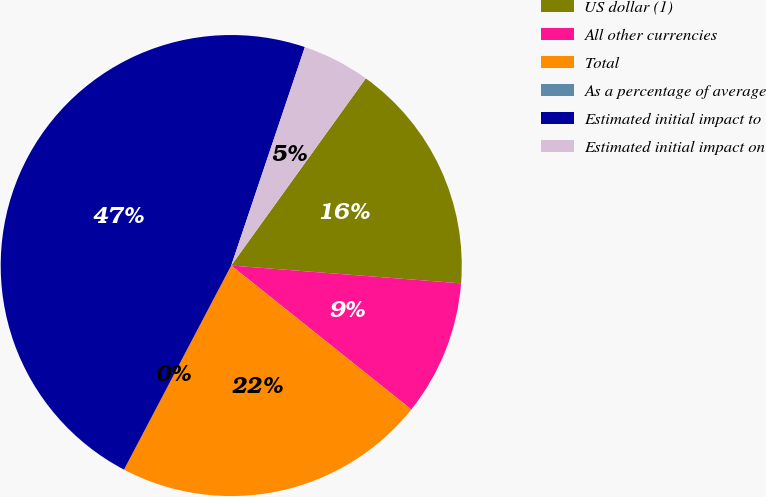Convert chart to OTSL. <chart><loc_0><loc_0><loc_500><loc_500><pie_chart><fcel>US dollar (1)<fcel>All other currencies<fcel>Total<fcel>As a percentage of average<fcel>Estimated initial impact to<fcel>Estimated initial impact on<nl><fcel>16.31%<fcel>9.5%<fcel>21.97%<fcel>0.0%<fcel>47.48%<fcel>4.75%<nl></chart> 